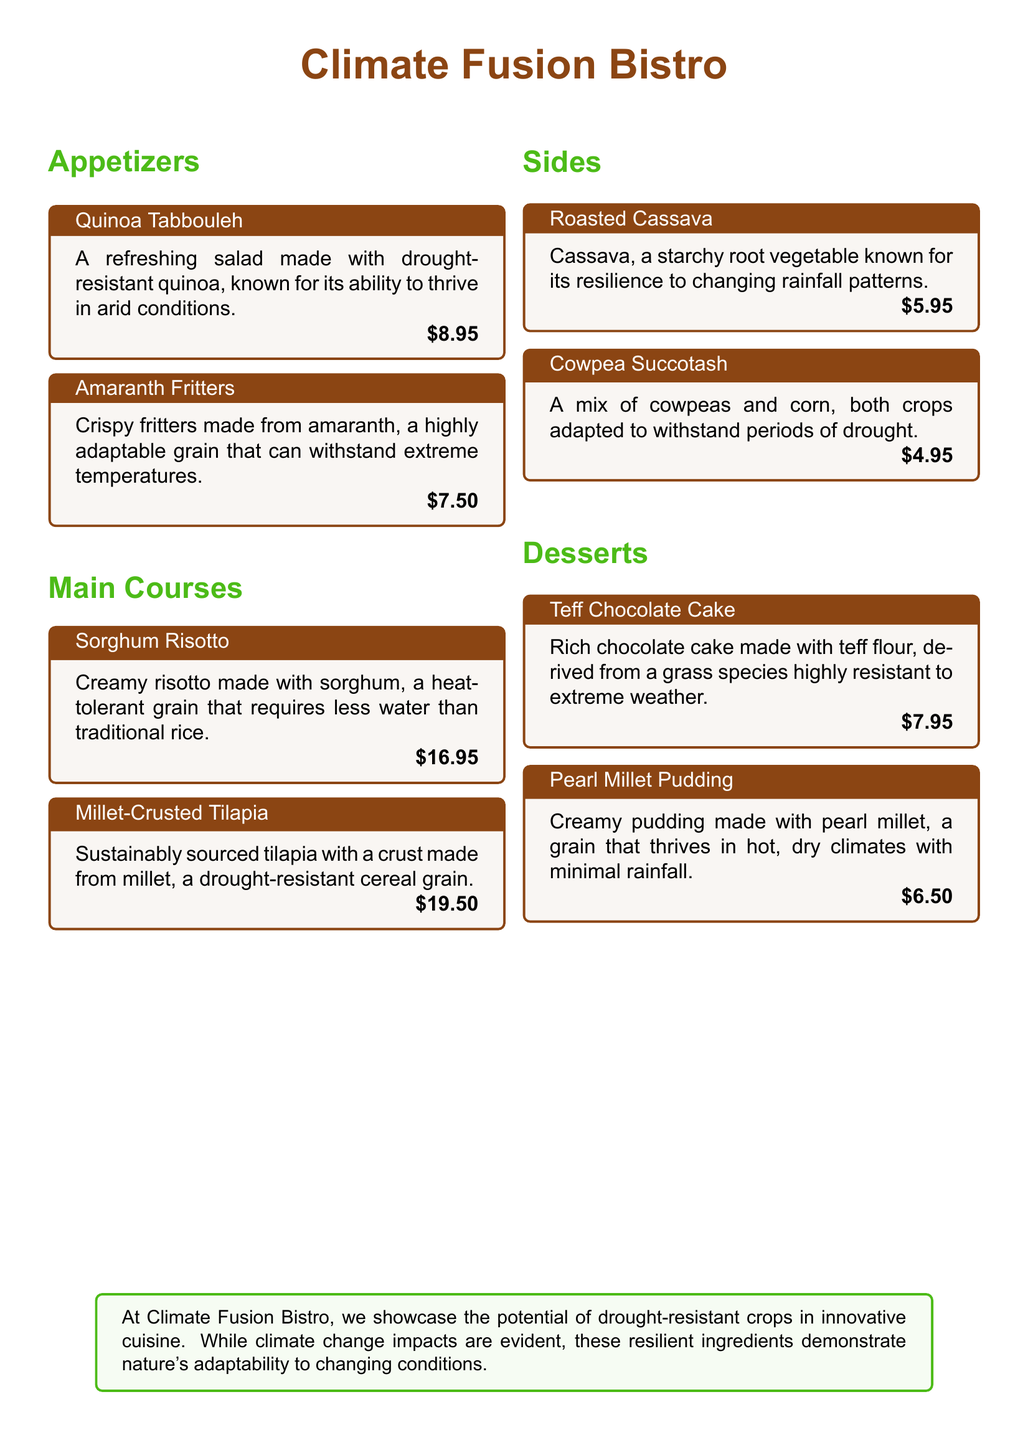What is the name of the restaurant? The name of the restaurant is mentioned at the top of the document.
Answer: Climate Fusion Bistro What is the price of the Amaranth Fritters? The price is listed under the Amaranth Fritters appetizer.
Answer: $7.50 Which crop is used in the Sorghum Risotto? The document specifies the main ingredient in the Sorghum Risotto.
Answer: Sorghum What dessert is made with teff flour? The dessert section includes a specific dessert made from teff flour.
Answer: Teff Chocolate Cake Which appetizer is known for thriving in arid conditions? The document states that the quinoa appetizer is particularly resilient.
Answer: Quinoa Tabbouleh How many side dishes are listed on the menu? To find this, count the distinct side dishes mentioned in the document.
Answer: 2 What ingredient in the Cowpea Succotash is drought-resistant? This question relates to the specific crops mentioned in the Cowpea Succotash.
Answer: Cowpeas Which dessert is made with pearl millet? The document mentions a specific dessert that utilizes pearl millet.
Answer: Pearl Millet Pudding What is highlighted about the ingredients in the restaurant's introduction? The introduction summarizes the characteristics of the restaurant's ingredients.
Answer: Resilience to changing conditions 